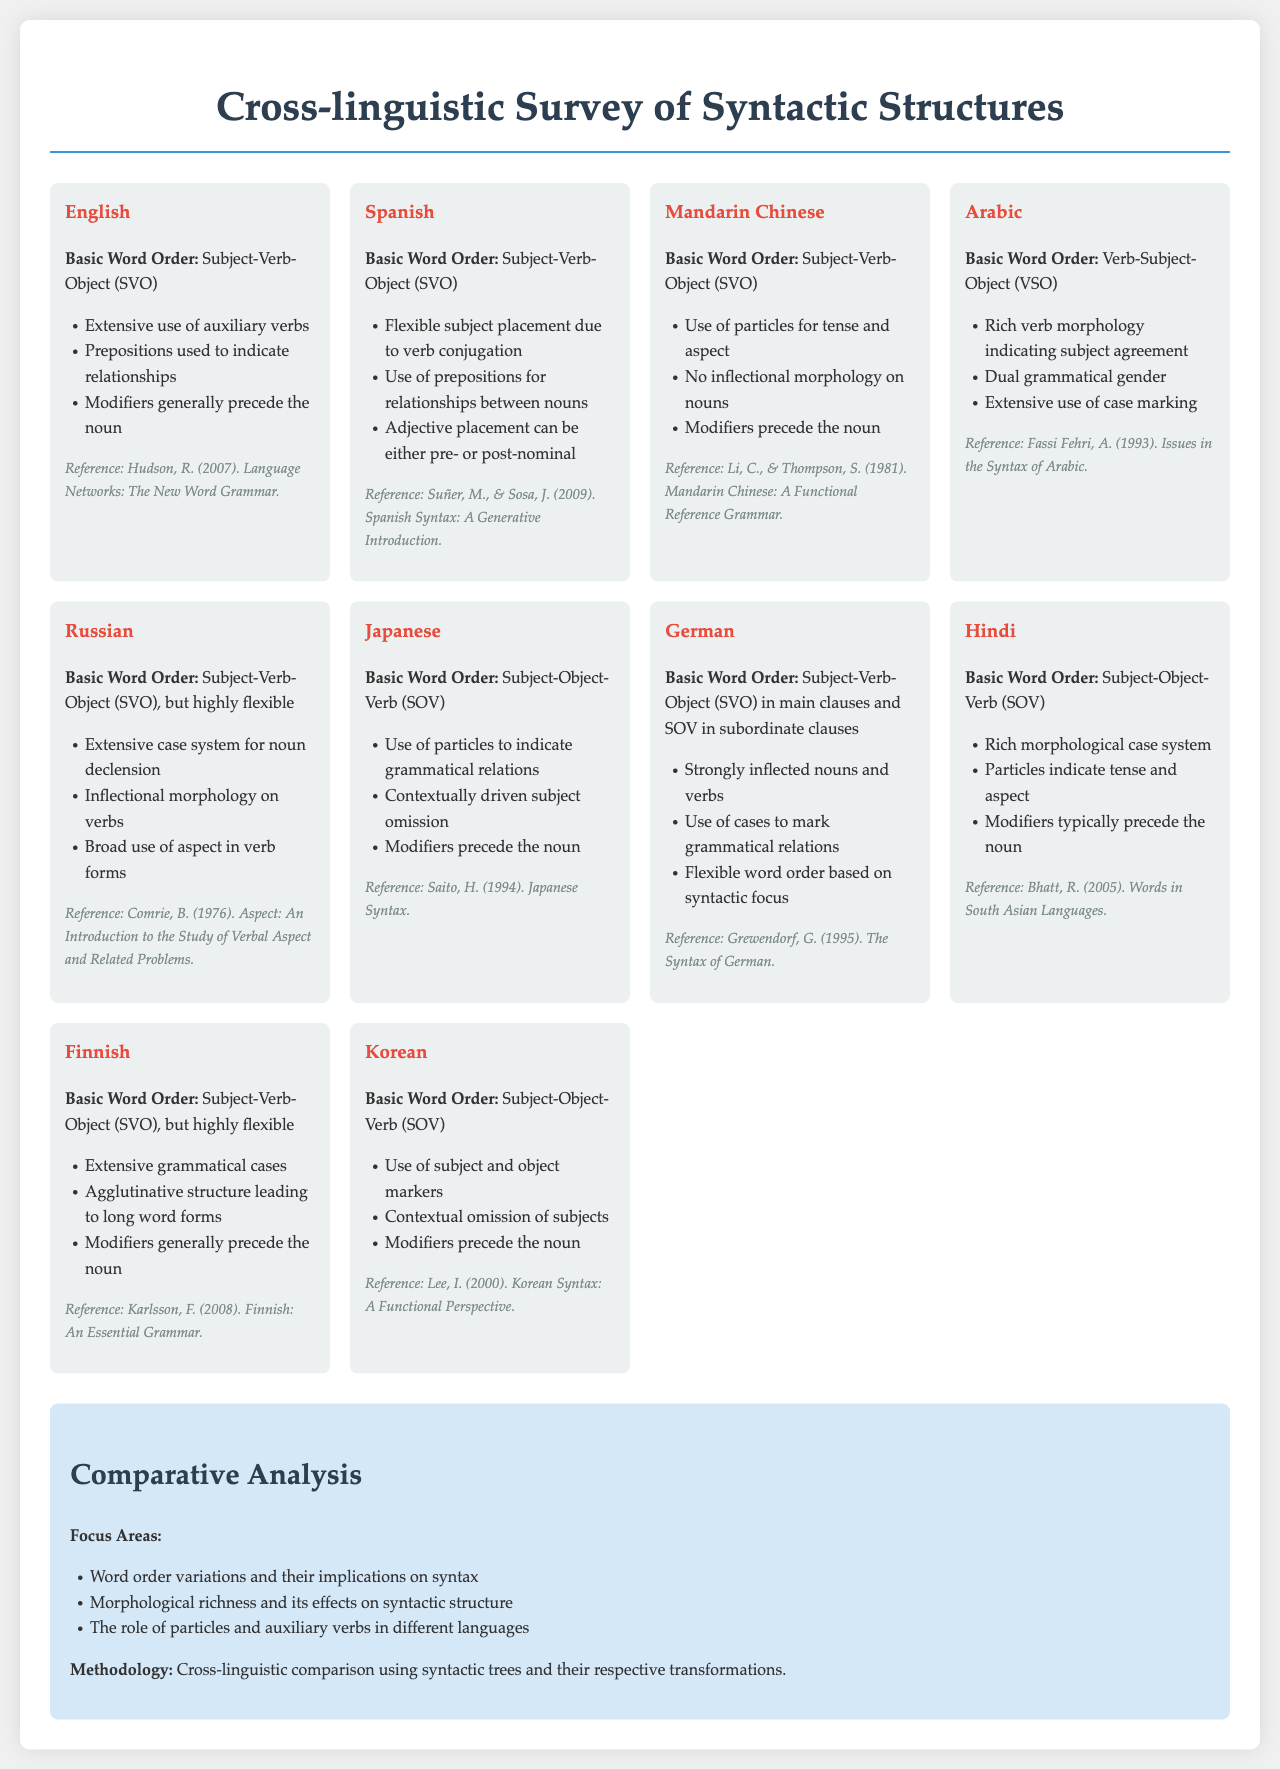What is the basic word order in English? The document states that the basic word order in English is Subject-Verb-Object (SVO).
Answer: Subject-Verb-Object (SVO) How many languages are compared in the survey? The document notes that the survey compares syntactic structures across 10 languages.
Answer: 10 What grammatical feature is noted in Arabic? The document mentions that Arabic has rich verb morphology indicating subject agreement.
Answer: Rich verb morphology What is the reference for Spanish syntax? The document lists the reference for Spanish syntax as Suñer, M., & Sosa, J. (2009).
Answer: Suñer, M., & Sosa, J. (2009) What basic word order does Japanese follow? The document specifies that the basic word order in Japanese is Subject-Object-Verb (SOV).
Answer: Subject-Object-Verb (SOV) What are the focus areas in the comparative analysis? The document states the focus areas include word order variations and morphological richness among others.
Answer: Word order variations and morphological richness What type of methodology is used for the survey? The document explains that the methodology involves cross-linguistic comparison using syntactic trees.
Answer: Cross-linguistic comparison Which language has a flexible word order but primarily follows SVO? The document indicates that Finnish has a flexible word order while primarily following SVO.
Answer: Finnish What is a key characteristic of Hindi syntax? The document states that Hindi has a rich morphological case system.
Answer: Rich morphological case system 